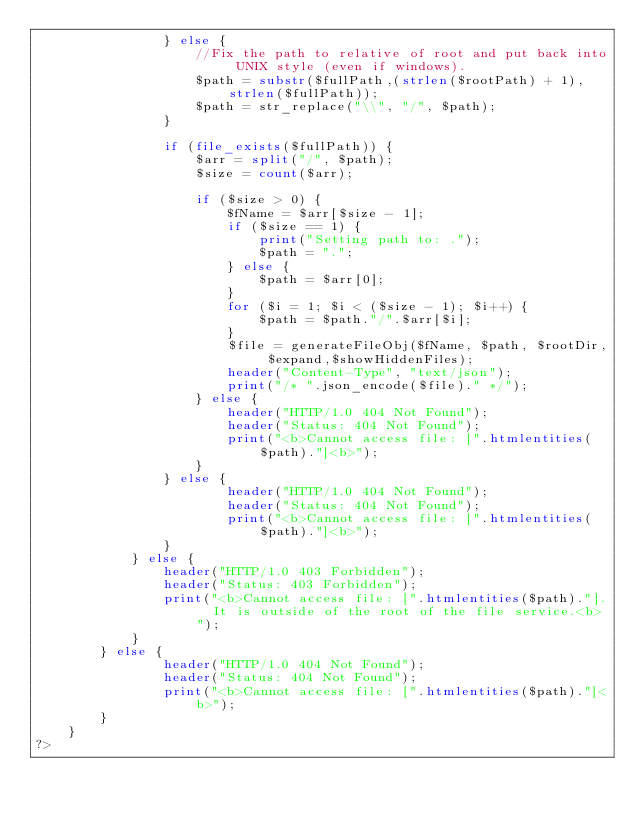<code> <loc_0><loc_0><loc_500><loc_500><_PHP_>				} else {
					//Fix the path to relative of root and put back into UNIX style (even if windows).
					$path = substr($fullPath,(strlen($rootPath) + 1),strlen($fullPath));
					$path = str_replace("\\", "/", $path);
				}

				if (file_exists($fullPath)) {
					$arr = split("/", $path);
					$size = count($arr);

					if ($size > 0) {
						$fName = $arr[$size - 1];
						if ($size == 1) {
							print("Setting path to: .");
							$path = ".";
						} else {
							$path = $arr[0];
						}
						for ($i = 1; $i < ($size - 1); $i++) {
							$path = $path."/".$arr[$i];
						}
						$file = generateFileObj($fName, $path, $rootDir, $expand,$showHiddenFiles);
						header("Content-Type", "text/json");
						print("/* ".json_encode($file)." */");
					} else {
						header("HTTP/1.0 404 Not Found");
						header("Status: 404 Not Found");
						print("<b>Cannot access file: [".htmlentities($path)."]<b>");
					}
				} else {
						header("HTTP/1.0 404 Not Found");
						header("Status: 404 Not Found");
						print("<b>Cannot access file: [".htmlentities($path)."]<b>");
				}
			} else {
				header("HTTP/1.0 403 Forbidden");
				header("Status: 403 Forbidden");
				print("<b>Cannot access file: [".htmlentities($path)."].  It is outside of the root of the file service.<b>");
			}
		} else {
				header("HTTP/1.0 404 Not Found");
				header("Status: 404 Not Found");
				print("<b>Cannot access file: [".htmlentities($path)."]<b>");
		}
	}
?>
</code> 